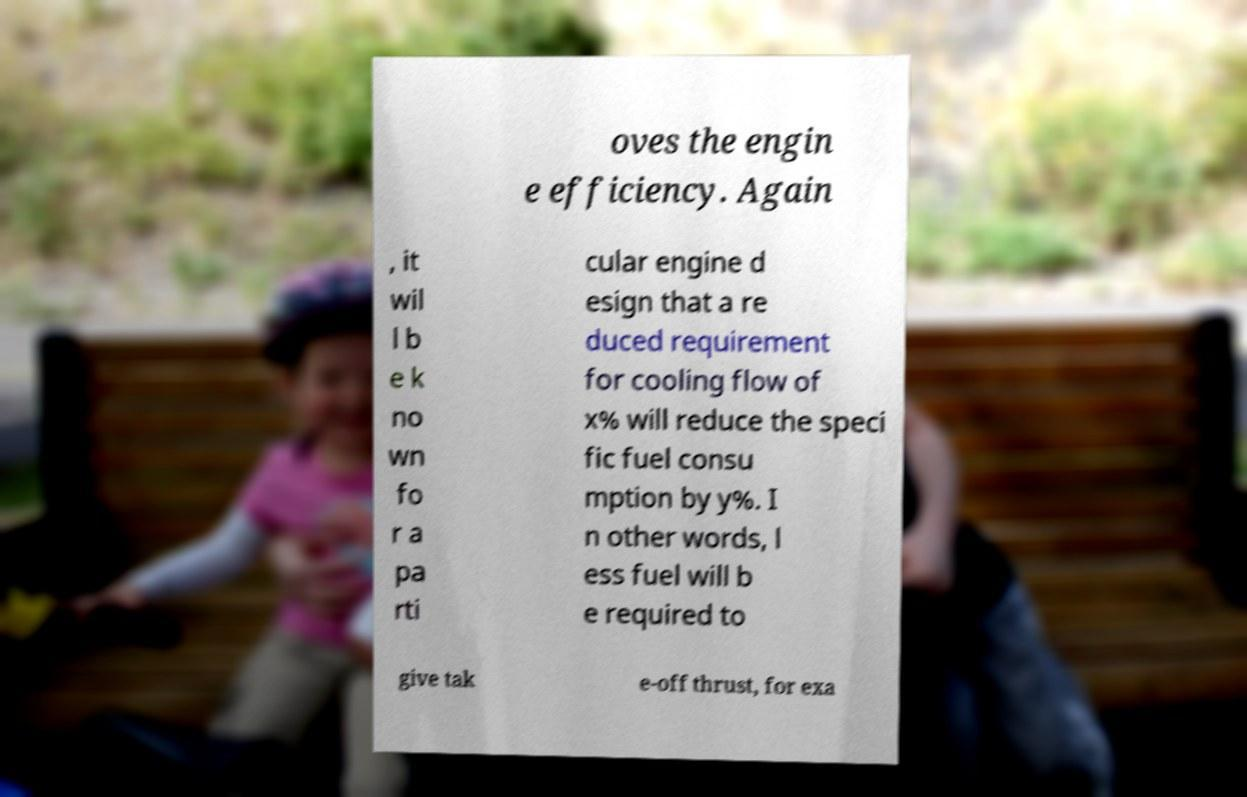Could you extract and type out the text from this image? oves the engin e efficiency. Again , it wil l b e k no wn fo r a pa rti cular engine d esign that a re duced requirement for cooling flow of x% will reduce the speci fic fuel consu mption by y%. I n other words, l ess fuel will b e required to give tak e-off thrust, for exa 